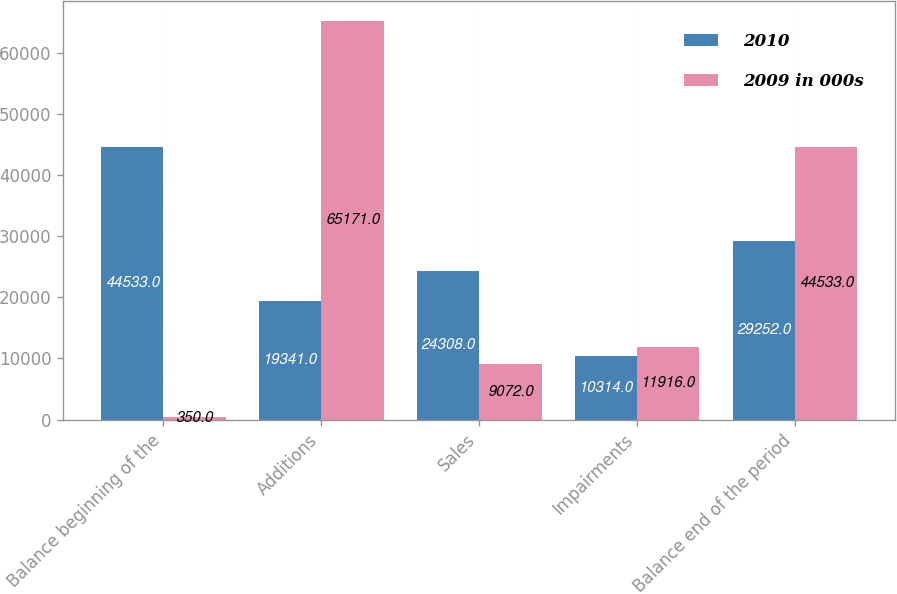<chart> <loc_0><loc_0><loc_500><loc_500><stacked_bar_chart><ecel><fcel>Balance beginning of the<fcel>Additions<fcel>Sales<fcel>Impairments<fcel>Balance end of the period<nl><fcel>2010<fcel>44533<fcel>19341<fcel>24308<fcel>10314<fcel>29252<nl><fcel>2009 in 000s<fcel>350<fcel>65171<fcel>9072<fcel>11916<fcel>44533<nl></chart> 